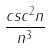<formula> <loc_0><loc_0><loc_500><loc_500>\frac { c s c ^ { 2 } n } { n ^ { 3 } }</formula> 